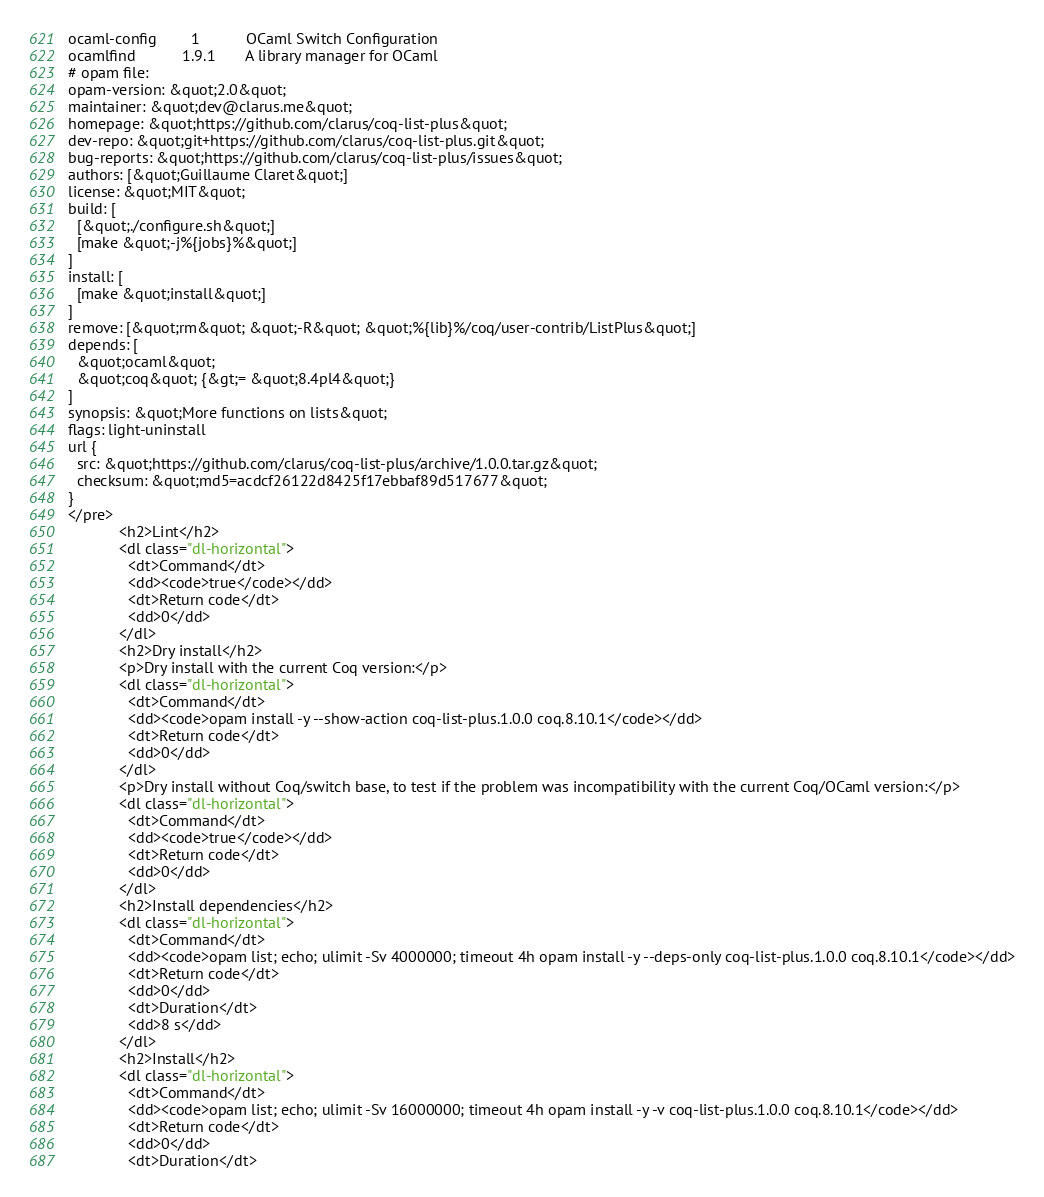Convert code to text. <code><loc_0><loc_0><loc_500><loc_500><_HTML_>ocaml-config        1           OCaml Switch Configuration
ocamlfind           1.9.1       A library manager for OCaml
# opam file:
opam-version: &quot;2.0&quot;
maintainer: &quot;dev@clarus.me&quot;
homepage: &quot;https://github.com/clarus/coq-list-plus&quot;
dev-repo: &quot;git+https://github.com/clarus/coq-list-plus.git&quot;
bug-reports: &quot;https://github.com/clarus/coq-list-plus/issues&quot;
authors: [&quot;Guillaume Claret&quot;]
license: &quot;MIT&quot;
build: [
  [&quot;./configure.sh&quot;]
  [make &quot;-j%{jobs}%&quot;]
]
install: [
  [make &quot;install&quot;]
]
remove: [&quot;rm&quot; &quot;-R&quot; &quot;%{lib}%/coq/user-contrib/ListPlus&quot;]
depends: [
  &quot;ocaml&quot;
  &quot;coq&quot; {&gt;= &quot;8.4pl4&quot;}
]
synopsis: &quot;More functions on lists&quot;
flags: light-uninstall
url {
  src: &quot;https://github.com/clarus/coq-list-plus/archive/1.0.0.tar.gz&quot;
  checksum: &quot;md5=acdcf26122d8425f17ebbaf89d517677&quot;
}
</pre>
            <h2>Lint</h2>
            <dl class="dl-horizontal">
              <dt>Command</dt>
              <dd><code>true</code></dd>
              <dt>Return code</dt>
              <dd>0</dd>
            </dl>
            <h2>Dry install</h2>
            <p>Dry install with the current Coq version:</p>
            <dl class="dl-horizontal">
              <dt>Command</dt>
              <dd><code>opam install -y --show-action coq-list-plus.1.0.0 coq.8.10.1</code></dd>
              <dt>Return code</dt>
              <dd>0</dd>
            </dl>
            <p>Dry install without Coq/switch base, to test if the problem was incompatibility with the current Coq/OCaml version:</p>
            <dl class="dl-horizontal">
              <dt>Command</dt>
              <dd><code>true</code></dd>
              <dt>Return code</dt>
              <dd>0</dd>
            </dl>
            <h2>Install dependencies</h2>
            <dl class="dl-horizontal">
              <dt>Command</dt>
              <dd><code>opam list; echo; ulimit -Sv 4000000; timeout 4h opam install -y --deps-only coq-list-plus.1.0.0 coq.8.10.1</code></dd>
              <dt>Return code</dt>
              <dd>0</dd>
              <dt>Duration</dt>
              <dd>8 s</dd>
            </dl>
            <h2>Install</h2>
            <dl class="dl-horizontal">
              <dt>Command</dt>
              <dd><code>opam list; echo; ulimit -Sv 16000000; timeout 4h opam install -y -v coq-list-plus.1.0.0 coq.8.10.1</code></dd>
              <dt>Return code</dt>
              <dd>0</dd>
              <dt>Duration</dt></code> 